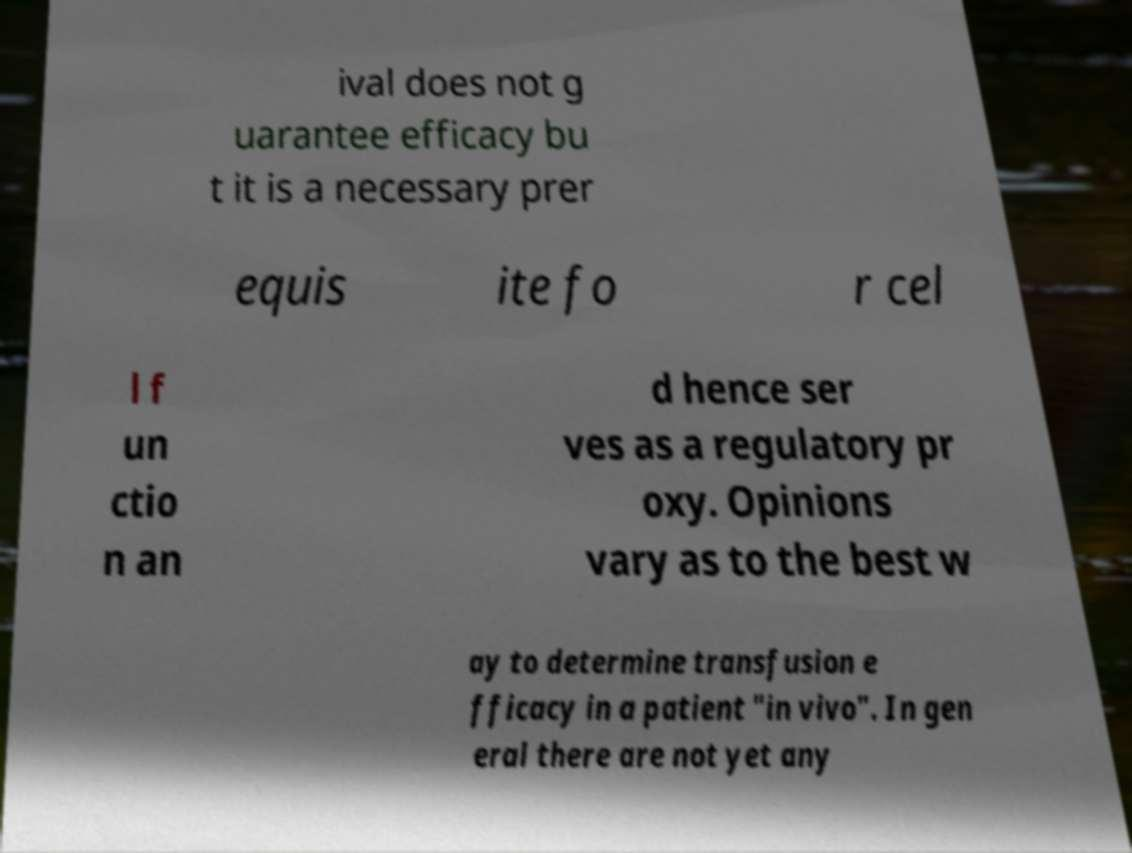Please read and relay the text visible in this image. What does it say? ival does not g uarantee efficacy bu t it is a necessary prer equis ite fo r cel l f un ctio n an d hence ser ves as a regulatory pr oxy. Opinions vary as to the best w ay to determine transfusion e fficacy in a patient "in vivo". In gen eral there are not yet any 